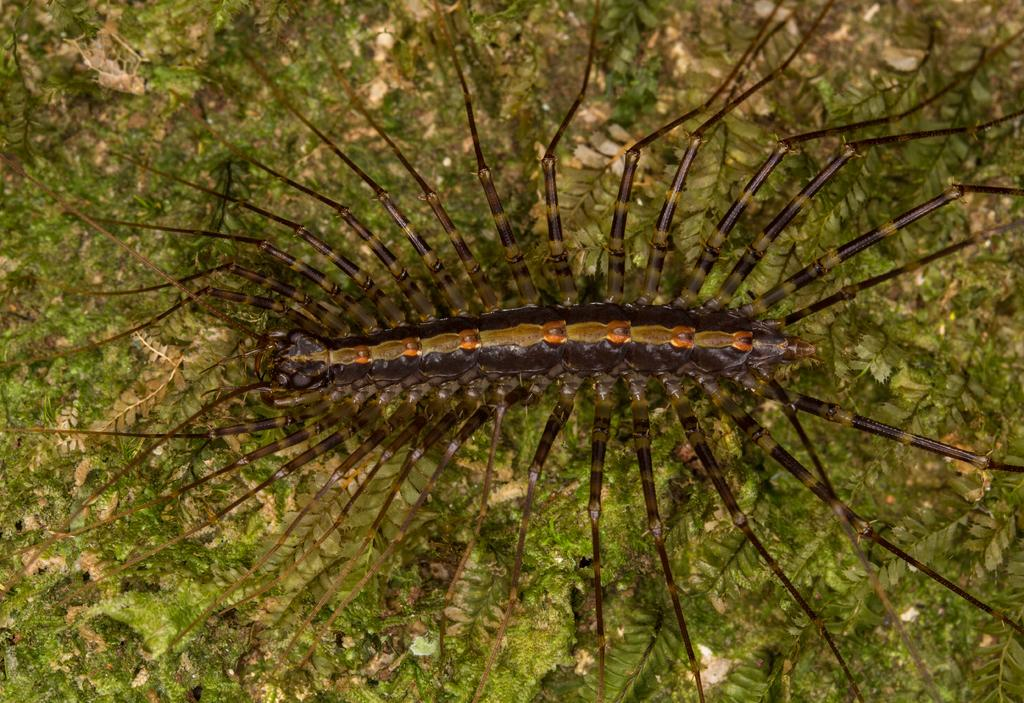What type of creature can be seen in the image? There is an insect in the image. What can be seen in the background of the image? There are leaves in the background of the image. What type of rose can be seen near the seashore in the image? There is no rose or seashore present in the image; it features an insect and leaves. What type of teeth can be seen on the insect in the image? Insects do not have teeth, so there are no teeth visible on the insect in the image. 